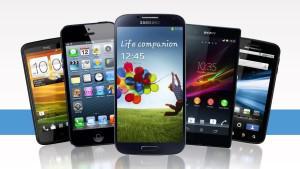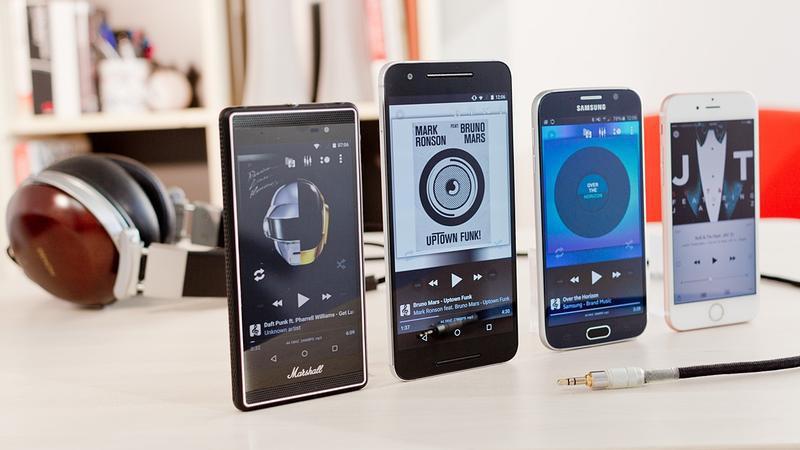The first image is the image on the left, the second image is the image on the right. Examine the images to the left and right. Is the description "Every image shows at least four devices and all screens show an image." accurate? Answer yes or no. Yes. The first image is the image on the left, the second image is the image on the right. Considering the images on both sides, is "One image contains exactly four phones, and the other image contains at least five phones." valid? Answer yes or no. Yes. 